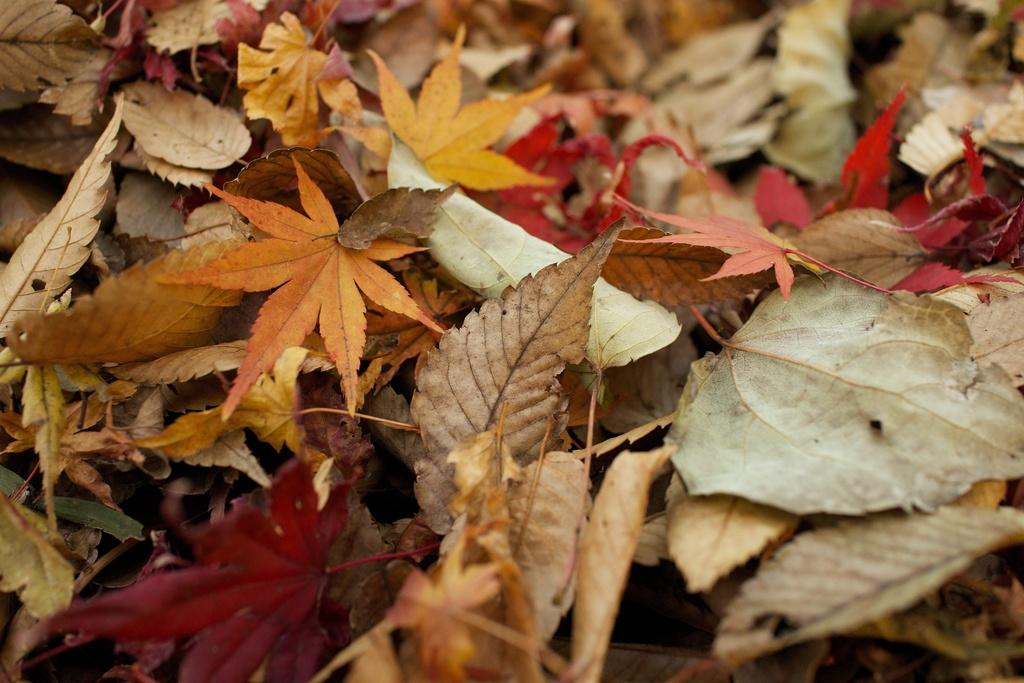What is on the ground in the image? There are leaves on the ground in the image. What can be observed about the leaves in terms of their appearance? The leaves are in different colors. How many fish can be seen swimming in the leaves in the image? There are no fish present in the image; it features leaves on the ground. What part of the image is made of jail bars? There are no jail bars present in the image; it features leaves on the ground. 